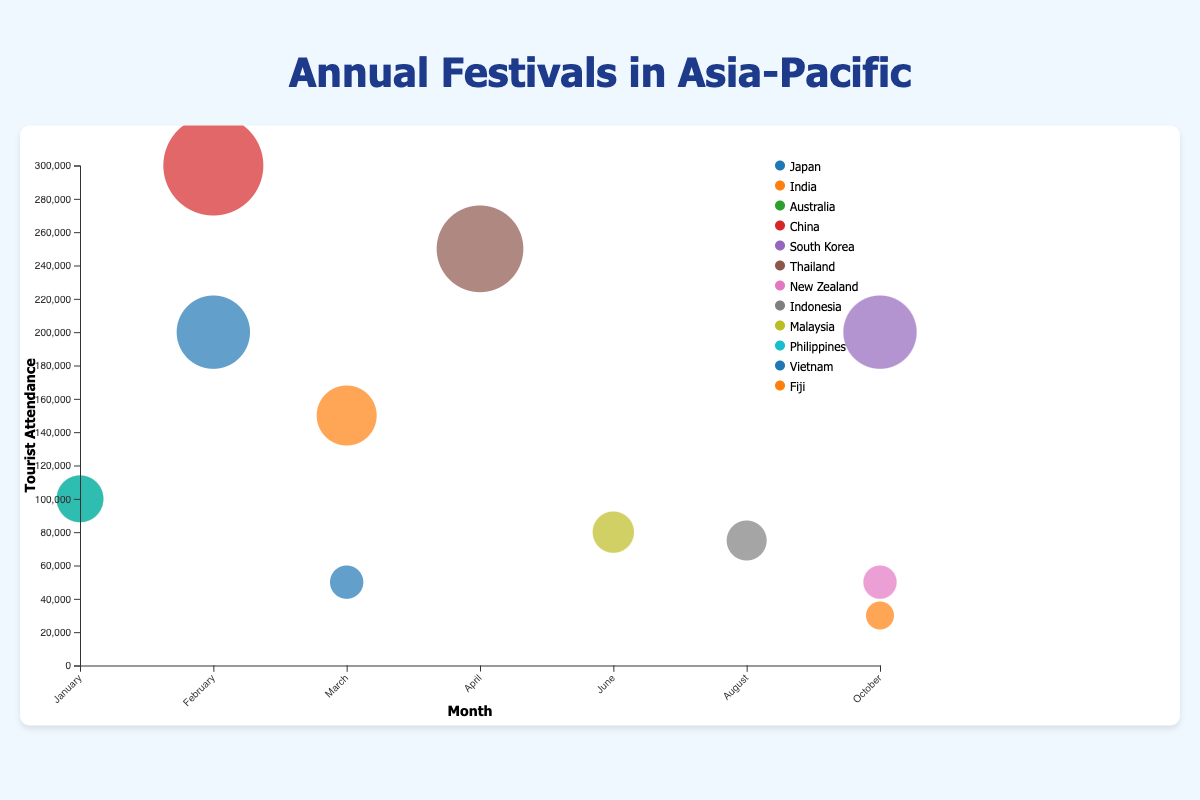In which month does China have its highest tourist attendance festival? Identify the bubble corresponding to China, look at the x-axis for its month.
Answer: February Which country has the festival with the highest tourist attendance and what is the attendance number? Find the largest bubble and check the corresponding color/country and its tourist attendance.
Answer: China, 300,000 How many festivals occur in October and which countries do they belong to? Count the bubbles under October on the x-axis and read off the countries associated with those bubbles.
Answer: 3, South Korea, New Zealand, Fiji Which festival has the lowest tourist attendance, and what is the number? Identify the smallest bubble and check its tooltip for the tourist attendance number.
Answer: Fiji Day, 30,000 Is the tourist attendance of Thailand's Songkran higher or lower than South Korea's Seoul Lantern Festival? Compare the sizes of Songkran's bubble to Seoul Lantern Festival's bubble on the y-axis.
Answer: Higher What is the combined tourist attendance in March for all the festivals? Identify all bubbles in March and sum their tourist attendances. (50,000 + 150,000) = 200,000
Answer: 200,000 Which countries have festivals that take place in January? Look at the bubbles under January and identify the associated countries.
Answer: Australia, Philippines Compare the tourist attendance of Vietnam's Tet Nguyen Dan and China's Chinese New Year. Which one is higher? Check the sizes of the Tet Nguyen Dan bubble and the Chinese New Year bubble, then compare.
Answer: Chinese New Year What is the average tourist attendance across all festivals depicted? Sum all tourist attendance numbers and divide by the number of festivals. Calculation: (50,000 + 150,000 + 100,000 + 300,000 + 200,000 + 250,000 + 50,000 + 75,000 + 80,000 + 100,000 + 200,000 + 30,000) / 12
Answer: 131,250 